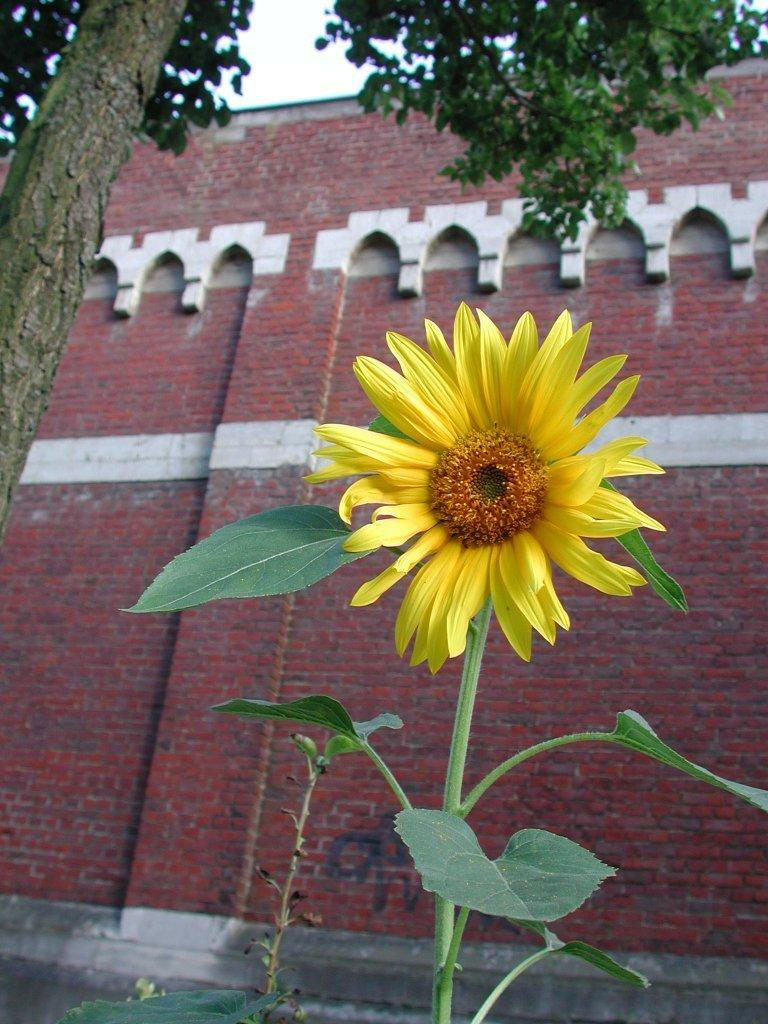What is the main subject in the foreground of the image? There is a flower in the foreground of the image. What can be seen in the background of the image? There is a building and trees in the background of the image. Is there any path or walkway visible in the image? Yes, there is a walkway at the bottom of the image. Where is the lunchroom located in the image? There is no lunchroom present in the image. How many islands can be seen in the image? There are no islands present in the image. 